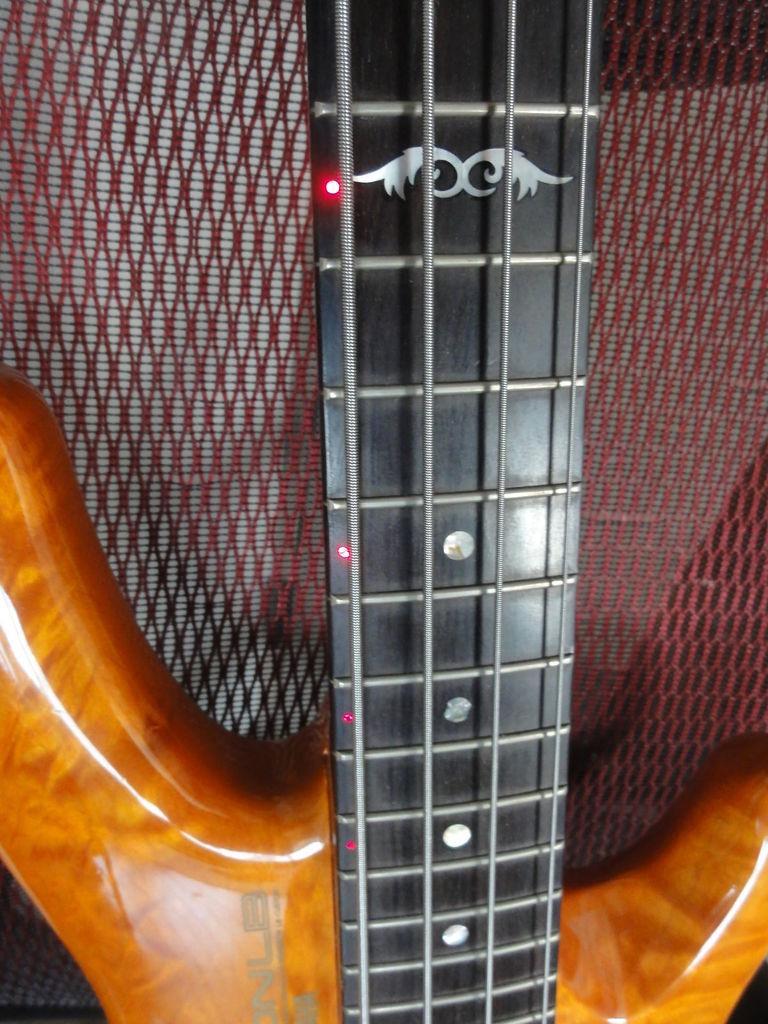Please provide a concise description of this image. In this image I see a guitar and I see there are strings on this guitar and I see the lights on it. 